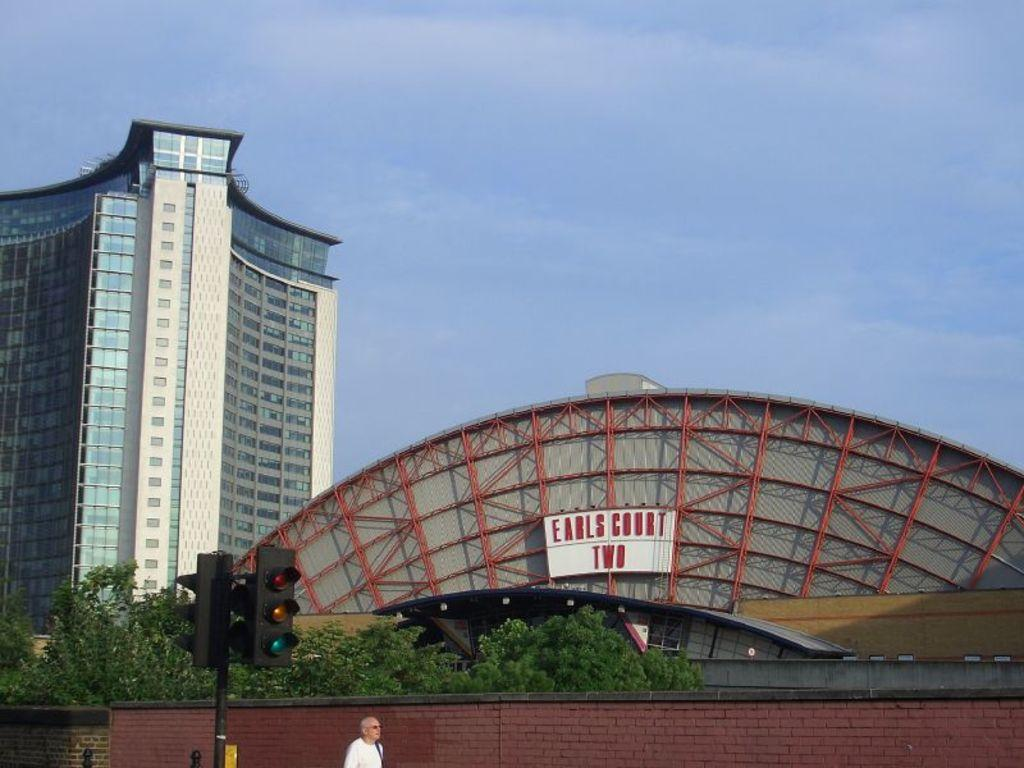What is the person wearing in the image? The person is wearing a white dress in the image. What can be seen near the person? There is a black colored pole and a traffic signal in the image. What is visible in the background of the image? There are trees, a wall, buildings, and the sky visible in the background of the image. Can you see a snake slithering on the wall in the image? There is no snake present in the image; only a person, a black colored pole, a traffic signal, trees, a wall, buildings, and the sky are visible. 